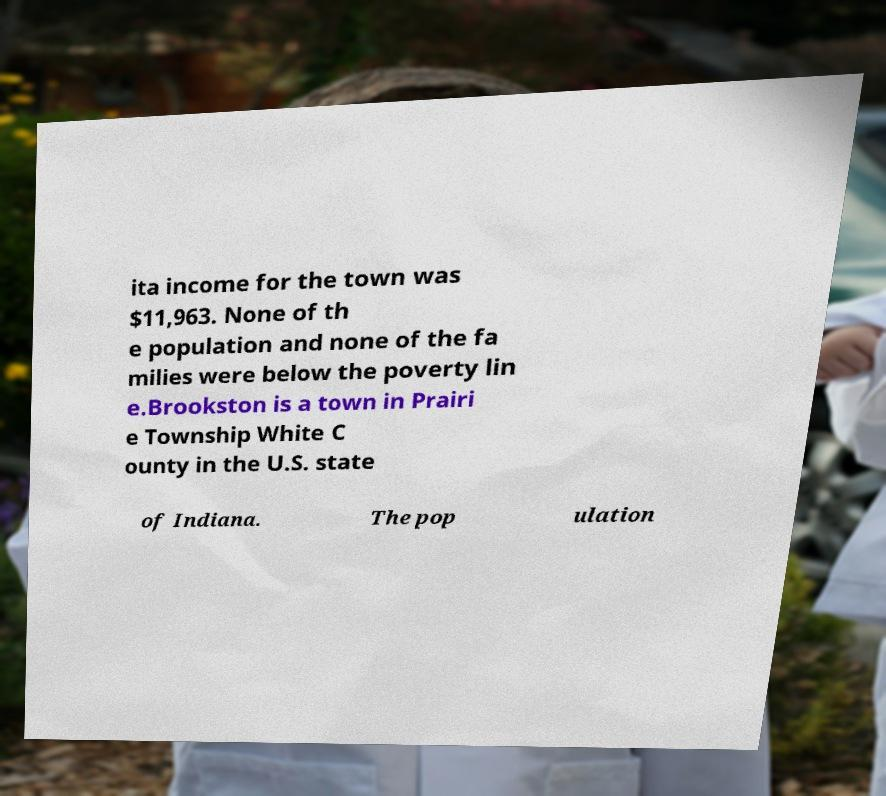Can you read and provide the text displayed in the image?This photo seems to have some interesting text. Can you extract and type it out for me? ita income for the town was $11,963. None of th e population and none of the fa milies were below the poverty lin e.Brookston is a town in Prairi e Township White C ounty in the U.S. state of Indiana. The pop ulation 